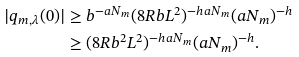Convert formula to latex. <formula><loc_0><loc_0><loc_500><loc_500>| q _ { m , \lambda } ( 0 ) | & \geq b ^ { - a N _ { m } } ( 8 R b L ^ { 2 } ) ^ { - h a N _ { m } } ( a N _ { m } ) ^ { - h } \\ & \geq ( 8 R b ^ { 2 } L ^ { 2 } ) ^ { - h a N _ { m } } ( a N _ { m } ) ^ { - h } .</formula> 